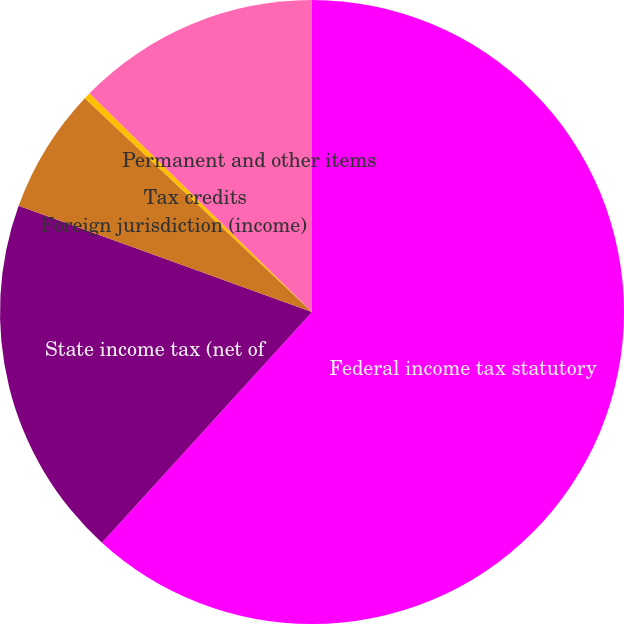Convert chart to OTSL. <chart><loc_0><loc_0><loc_500><loc_500><pie_chart><fcel>Federal income tax statutory<fcel>State income tax (net of<fcel>Foreign jurisdiction (income)<fcel>Tax credits<fcel>Permanent and other items<nl><fcel>61.75%<fcel>18.77%<fcel>6.49%<fcel>0.35%<fcel>12.63%<nl></chart> 